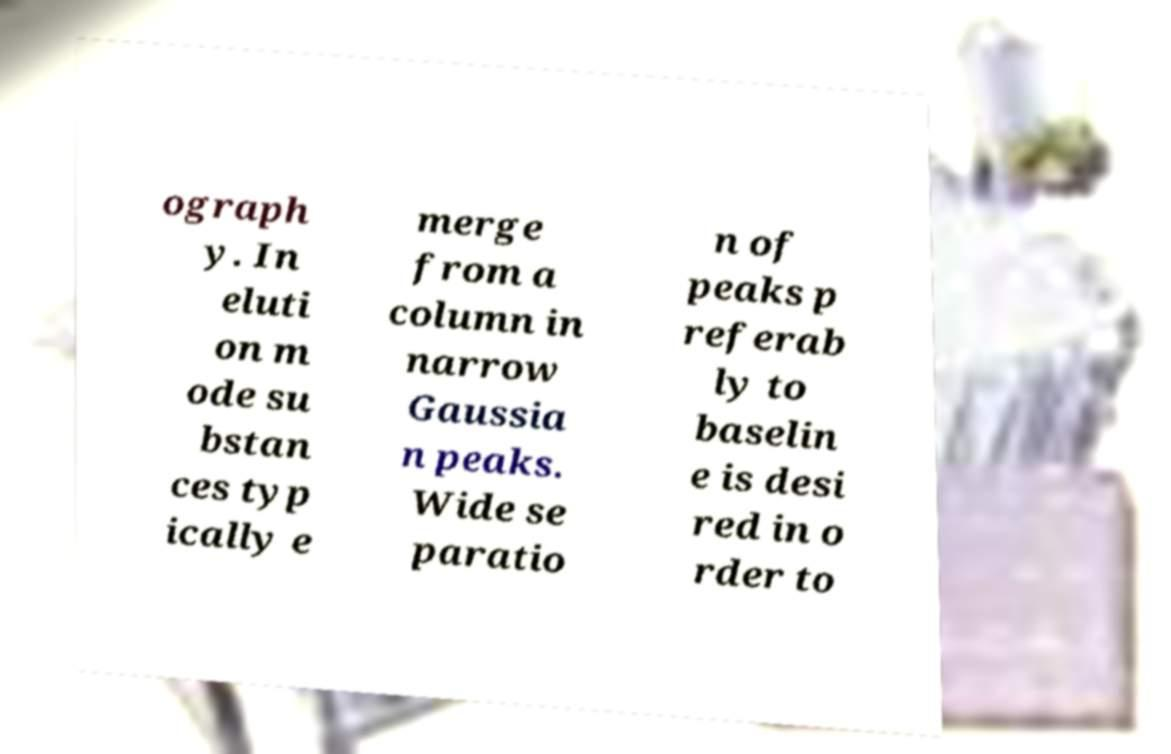I need the written content from this picture converted into text. Can you do that? ograph y. In eluti on m ode su bstan ces typ ically e merge from a column in narrow Gaussia n peaks. Wide se paratio n of peaks p referab ly to baselin e is desi red in o rder to 